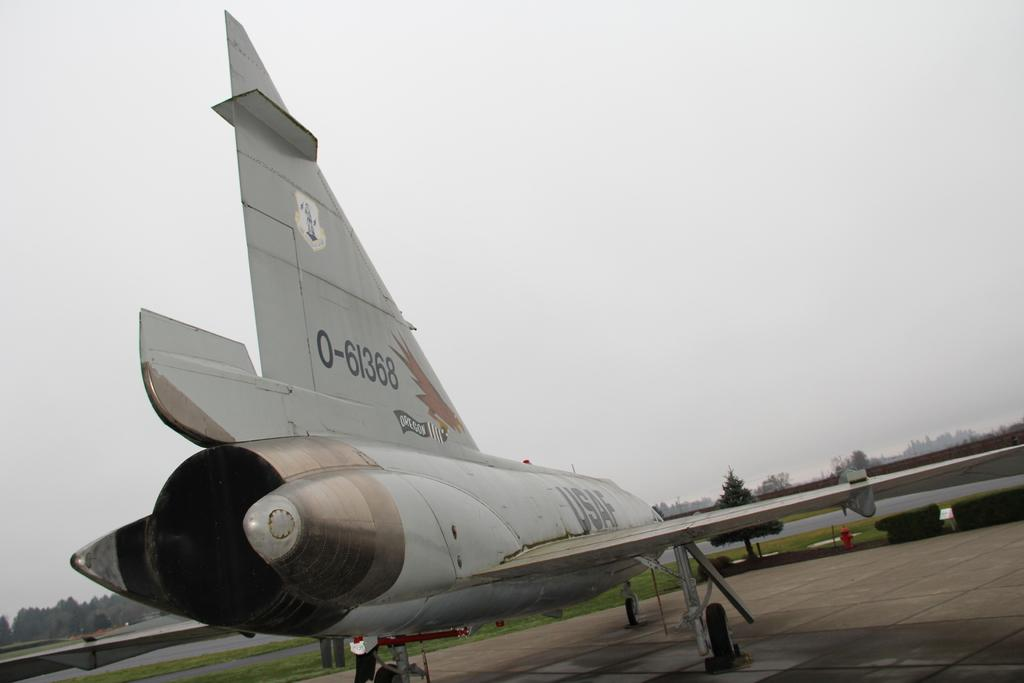<image>
Create a compact narrative representing the image presented. A grey plane is designated by 0-61368 on the tail. 